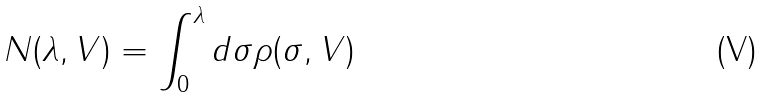Convert formula to latex. <formula><loc_0><loc_0><loc_500><loc_500>N ( \lambda , V ) = \int _ { 0 } ^ { \lambda } d \sigma \rho ( \sigma , V )</formula> 